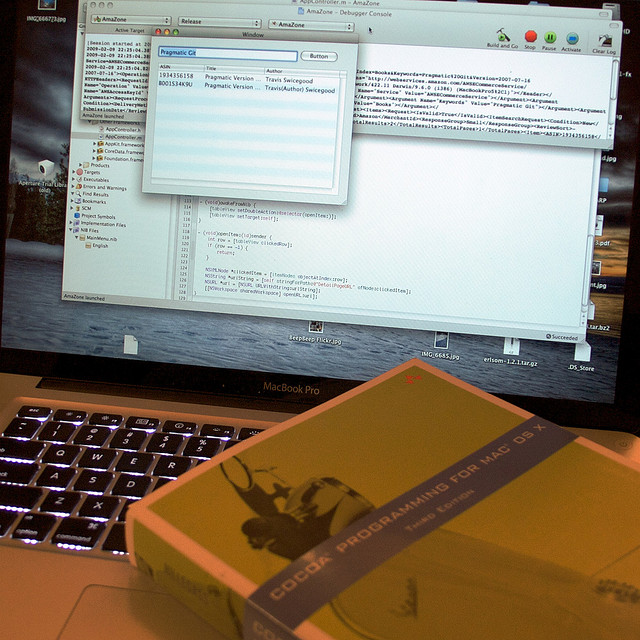<image>What letters are the man typing? It is ambiguous what letters the man is typing. What program is showing on the screen? It's not certain what program is showing on the screen. It can be either email, cocoa, windows, mac text, word or xcode. What letters are the man typing? I am not sure what letters the man is typing. It can be any combination of letters. What program is showing on the screen? I don't know what program is showing on the screen. It can be 'email', 'cocoa', 'unknown', 'windows', 'mac text', 'word', or 'xcode'. 